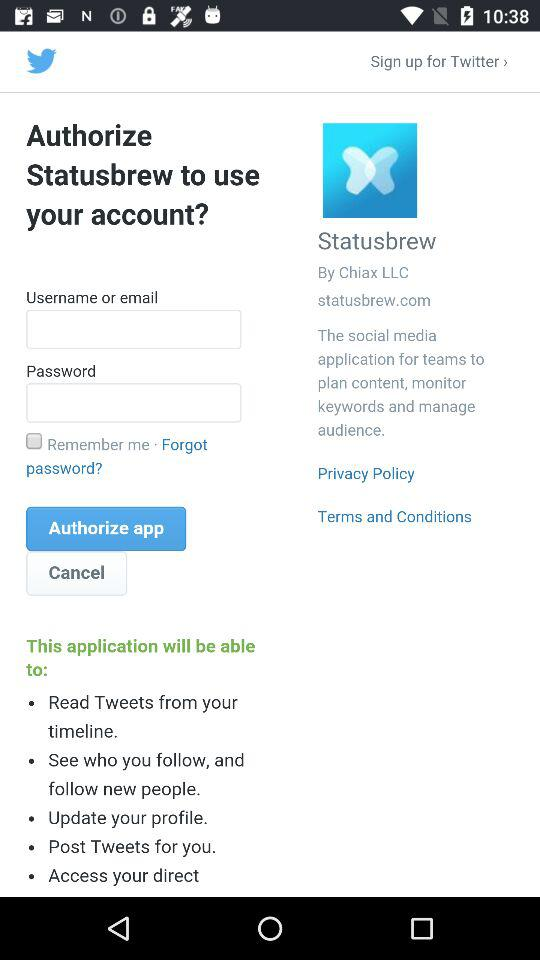What is the name of the company? The name of the company is "Statusbrew". 